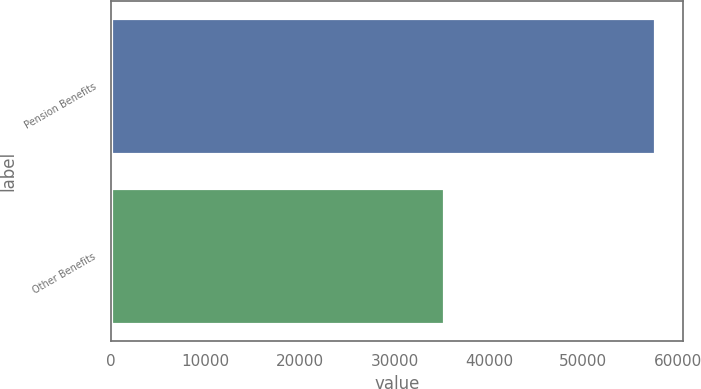<chart> <loc_0><loc_0><loc_500><loc_500><bar_chart><fcel>Pension Benefits<fcel>Other Benefits<nl><fcel>57619<fcel>35240<nl></chart> 